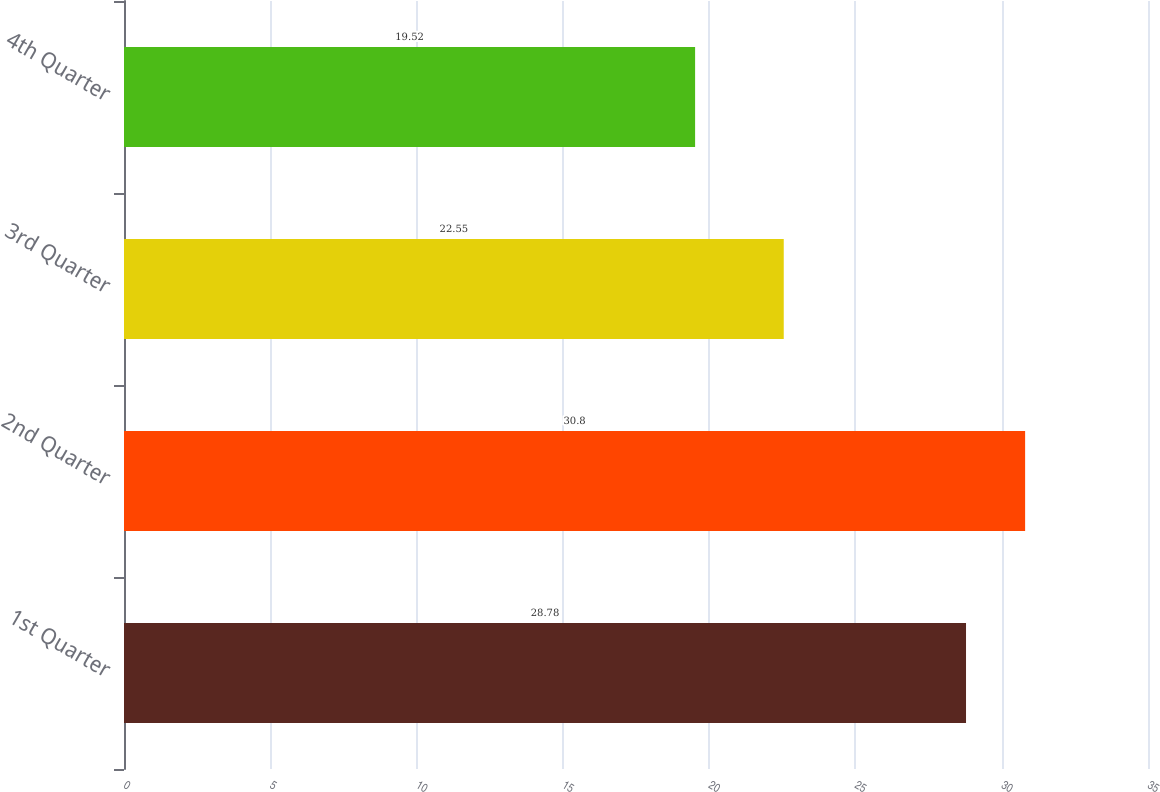<chart> <loc_0><loc_0><loc_500><loc_500><bar_chart><fcel>1st Quarter<fcel>2nd Quarter<fcel>3rd Quarter<fcel>4th Quarter<nl><fcel>28.78<fcel>30.8<fcel>22.55<fcel>19.52<nl></chart> 